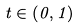Convert formula to latex. <formula><loc_0><loc_0><loc_500><loc_500>t \in \left ( 0 , 1 \right )</formula> 